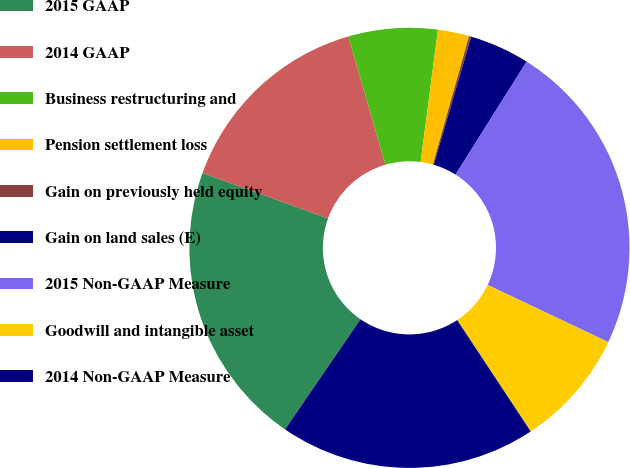Convert chart. <chart><loc_0><loc_0><loc_500><loc_500><pie_chart><fcel>2015 GAAP<fcel>2014 GAAP<fcel>Business restructuring and<fcel>Pension settlement loss<fcel>Gain on previously held equity<fcel>Gain on land sales (E)<fcel>2015 Non-GAAP Measure<fcel>Goodwill and intangible asset<fcel>2014 Non-GAAP Measure<nl><fcel>20.96%<fcel>14.99%<fcel>6.55%<fcel>2.3%<fcel>0.16%<fcel>4.41%<fcel>23.1%<fcel>8.66%<fcel>18.85%<nl></chart> 